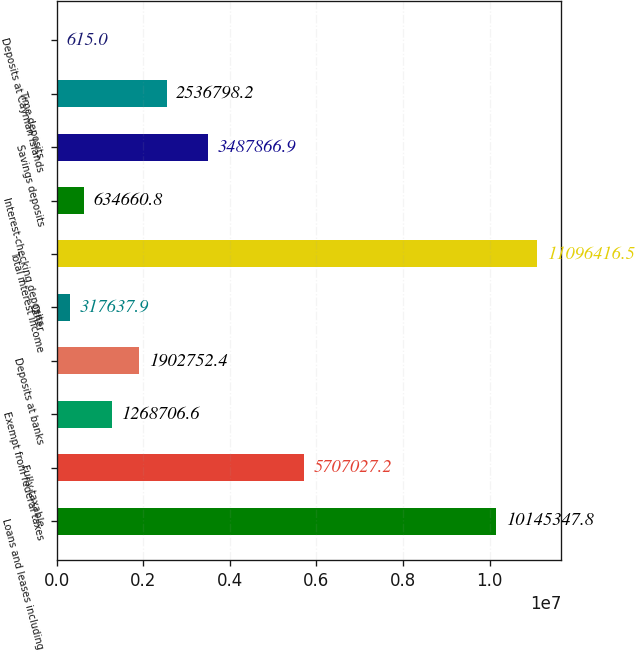Convert chart to OTSL. <chart><loc_0><loc_0><loc_500><loc_500><bar_chart><fcel>Loans and leases including<fcel>Fully taxable<fcel>Exempt from federal taxes<fcel>Deposits at banks<fcel>Other<fcel>Total interest income<fcel>Interest-checking deposits<fcel>Savings deposits<fcel>Time deposits<fcel>Deposits at Cayman Islands<nl><fcel>1.01453e+07<fcel>5.70703e+06<fcel>1.26871e+06<fcel>1.90275e+06<fcel>317638<fcel>1.10964e+07<fcel>634661<fcel>3.48787e+06<fcel>2.5368e+06<fcel>615<nl></chart> 